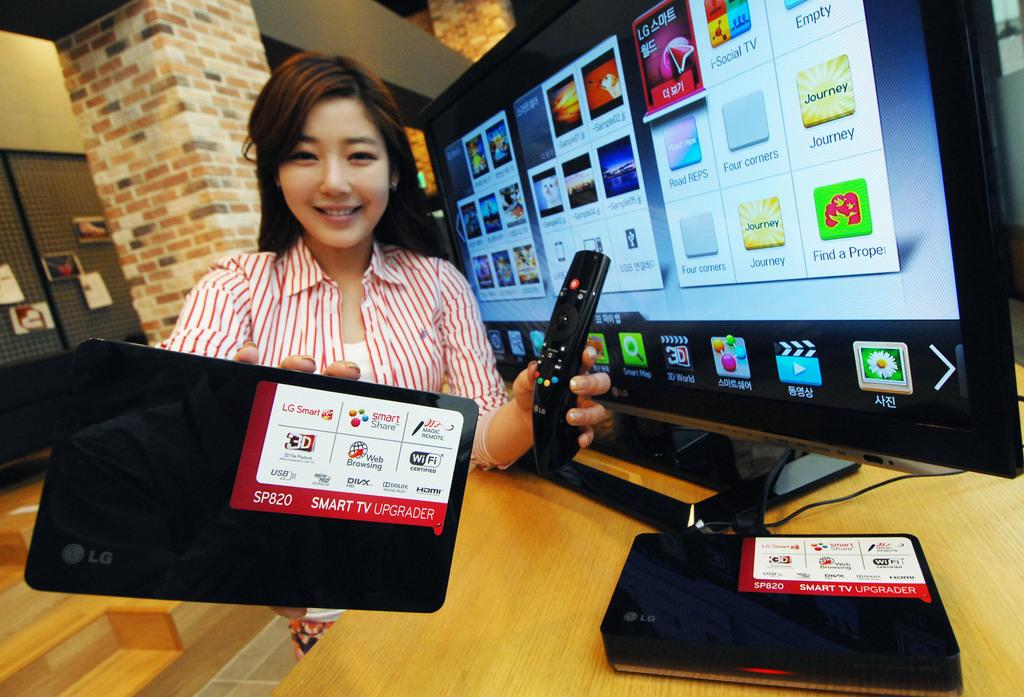<image>
Present a compact description of the photo's key features. Woman holding a LG phone next to a LG monitor. 